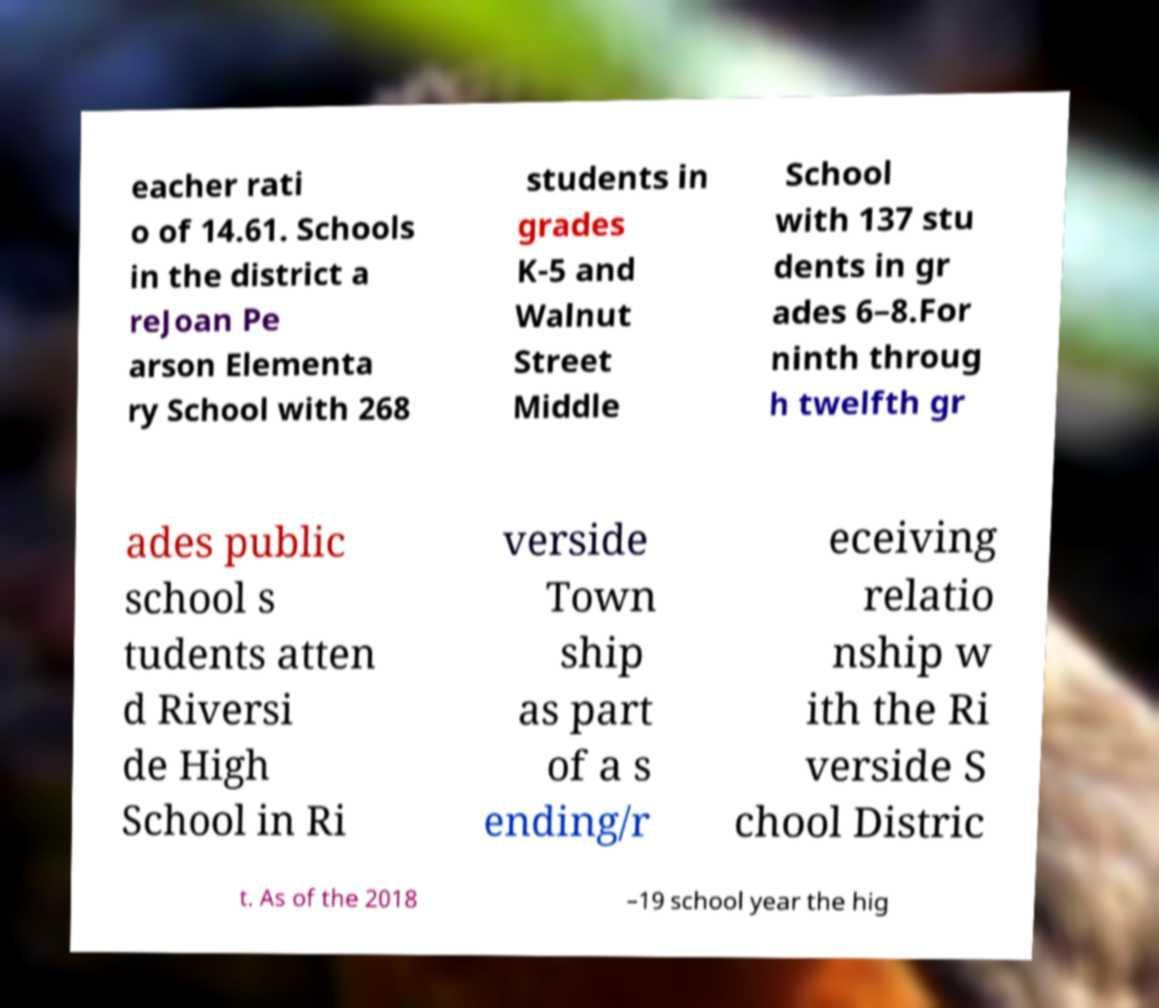For documentation purposes, I need the text within this image transcribed. Could you provide that? eacher rati o of 14.61. Schools in the district a reJoan Pe arson Elementa ry School with 268 students in grades K-5 and Walnut Street Middle School with 137 stu dents in gr ades 6–8.For ninth throug h twelfth gr ades public school s tudents atten d Riversi de High School in Ri verside Town ship as part of a s ending/r eceiving relatio nship w ith the Ri verside S chool Distric t. As of the 2018 –19 school year the hig 